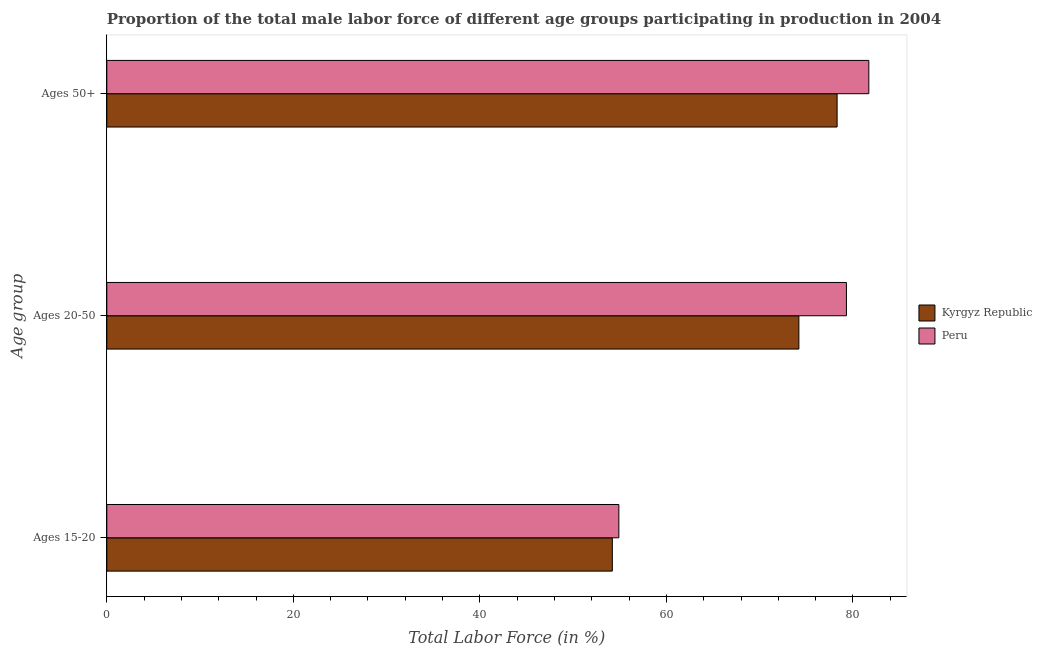How many groups of bars are there?
Make the answer very short. 3. Are the number of bars on each tick of the Y-axis equal?
Keep it short and to the point. Yes. What is the label of the 2nd group of bars from the top?
Make the answer very short. Ages 20-50. What is the percentage of male labor force within the age group 15-20 in Kyrgyz Republic?
Your answer should be very brief. 54.2. Across all countries, what is the maximum percentage of male labor force within the age group 15-20?
Make the answer very short. 54.9. Across all countries, what is the minimum percentage of male labor force above age 50?
Provide a succinct answer. 78.3. In which country was the percentage of male labor force above age 50 minimum?
Provide a succinct answer. Kyrgyz Republic. What is the total percentage of male labor force above age 50 in the graph?
Your answer should be compact. 160. What is the difference between the percentage of male labor force within the age group 20-50 in Peru and that in Kyrgyz Republic?
Offer a terse response. 5.1. What is the average percentage of male labor force within the age group 20-50 per country?
Ensure brevity in your answer.  76.75. What is the difference between the percentage of male labor force within the age group 15-20 and percentage of male labor force within the age group 20-50 in Kyrgyz Republic?
Make the answer very short. -20. What is the ratio of the percentage of male labor force within the age group 20-50 in Peru to that in Kyrgyz Republic?
Ensure brevity in your answer.  1.07. What is the difference between the highest and the second highest percentage of male labor force above age 50?
Make the answer very short. 3.4. What is the difference between the highest and the lowest percentage of male labor force above age 50?
Your answer should be compact. 3.4. What does the 2nd bar from the top in Ages 15-20 represents?
Provide a succinct answer. Kyrgyz Republic. What does the 1st bar from the bottom in Ages 20-50 represents?
Provide a succinct answer. Kyrgyz Republic. Is it the case that in every country, the sum of the percentage of male labor force within the age group 15-20 and percentage of male labor force within the age group 20-50 is greater than the percentage of male labor force above age 50?
Your answer should be very brief. Yes. Are all the bars in the graph horizontal?
Your answer should be compact. Yes. Are the values on the major ticks of X-axis written in scientific E-notation?
Keep it short and to the point. No. Does the graph contain any zero values?
Your response must be concise. No. Where does the legend appear in the graph?
Provide a succinct answer. Center right. How many legend labels are there?
Provide a succinct answer. 2. How are the legend labels stacked?
Your answer should be very brief. Vertical. What is the title of the graph?
Provide a short and direct response. Proportion of the total male labor force of different age groups participating in production in 2004. What is the label or title of the X-axis?
Offer a very short reply. Total Labor Force (in %). What is the label or title of the Y-axis?
Your answer should be very brief. Age group. What is the Total Labor Force (in %) in Kyrgyz Republic in Ages 15-20?
Your answer should be very brief. 54.2. What is the Total Labor Force (in %) in Peru in Ages 15-20?
Give a very brief answer. 54.9. What is the Total Labor Force (in %) in Kyrgyz Republic in Ages 20-50?
Offer a very short reply. 74.2. What is the Total Labor Force (in %) of Peru in Ages 20-50?
Provide a short and direct response. 79.3. What is the Total Labor Force (in %) in Kyrgyz Republic in Ages 50+?
Provide a short and direct response. 78.3. What is the Total Labor Force (in %) in Peru in Ages 50+?
Provide a short and direct response. 81.7. Across all Age group, what is the maximum Total Labor Force (in %) of Kyrgyz Republic?
Your answer should be very brief. 78.3. Across all Age group, what is the maximum Total Labor Force (in %) in Peru?
Provide a short and direct response. 81.7. Across all Age group, what is the minimum Total Labor Force (in %) of Kyrgyz Republic?
Keep it short and to the point. 54.2. Across all Age group, what is the minimum Total Labor Force (in %) of Peru?
Give a very brief answer. 54.9. What is the total Total Labor Force (in %) in Kyrgyz Republic in the graph?
Provide a succinct answer. 206.7. What is the total Total Labor Force (in %) of Peru in the graph?
Give a very brief answer. 215.9. What is the difference between the Total Labor Force (in %) of Peru in Ages 15-20 and that in Ages 20-50?
Give a very brief answer. -24.4. What is the difference between the Total Labor Force (in %) in Kyrgyz Republic in Ages 15-20 and that in Ages 50+?
Your answer should be very brief. -24.1. What is the difference between the Total Labor Force (in %) of Peru in Ages 15-20 and that in Ages 50+?
Give a very brief answer. -26.8. What is the difference between the Total Labor Force (in %) in Kyrgyz Republic in Ages 20-50 and that in Ages 50+?
Your answer should be very brief. -4.1. What is the difference between the Total Labor Force (in %) in Kyrgyz Republic in Ages 15-20 and the Total Labor Force (in %) in Peru in Ages 20-50?
Your answer should be compact. -25.1. What is the difference between the Total Labor Force (in %) of Kyrgyz Republic in Ages 15-20 and the Total Labor Force (in %) of Peru in Ages 50+?
Your answer should be compact. -27.5. What is the average Total Labor Force (in %) of Kyrgyz Republic per Age group?
Your response must be concise. 68.9. What is the average Total Labor Force (in %) in Peru per Age group?
Ensure brevity in your answer.  71.97. What is the ratio of the Total Labor Force (in %) of Kyrgyz Republic in Ages 15-20 to that in Ages 20-50?
Your answer should be compact. 0.73. What is the ratio of the Total Labor Force (in %) in Peru in Ages 15-20 to that in Ages 20-50?
Offer a very short reply. 0.69. What is the ratio of the Total Labor Force (in %) in Kyrgyz Republic in Ages 15-20 to that in Ages 50+?
Provide a short and direct response. 0.69. What is the ratio of the Total Labor Force (in %) of Peru in Ages 15-20 to that in Ages 50+?
Your answer should be very brief. 0.67. What is the ratio of the Total Labor Force (in %) of Kyrgyz Republic in Ages 20-50 to that in Ages 50+?
Offer a terse response. 0.95. What is the ratio of the Total Labor Force (in %) in Peru in Ages 20-50 to that in Ages 50+?
Your response must be concise. 0.97. What is the difference between the highest and the second highest Total Labor Force (in %) of Peru?
Provide a short and direct response. 2.4. What is the difference between the highest and the lowest Total Labor Force (in %) in Kyrgyz Republic?
Your answer should be very brief. 24.1. What is the difference between the highest and the lowest Total Labor Force (in %) in Peru?
Keep it short and to the point. 26.8. 